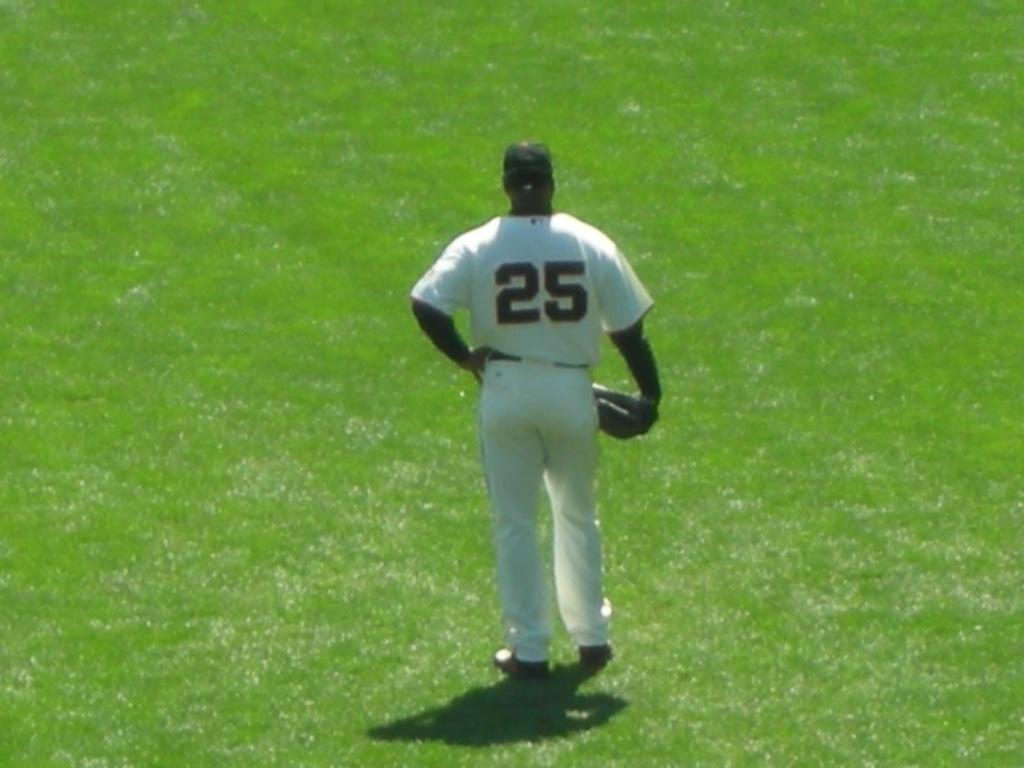What is this player's number?
Offer a terse response. 25. 